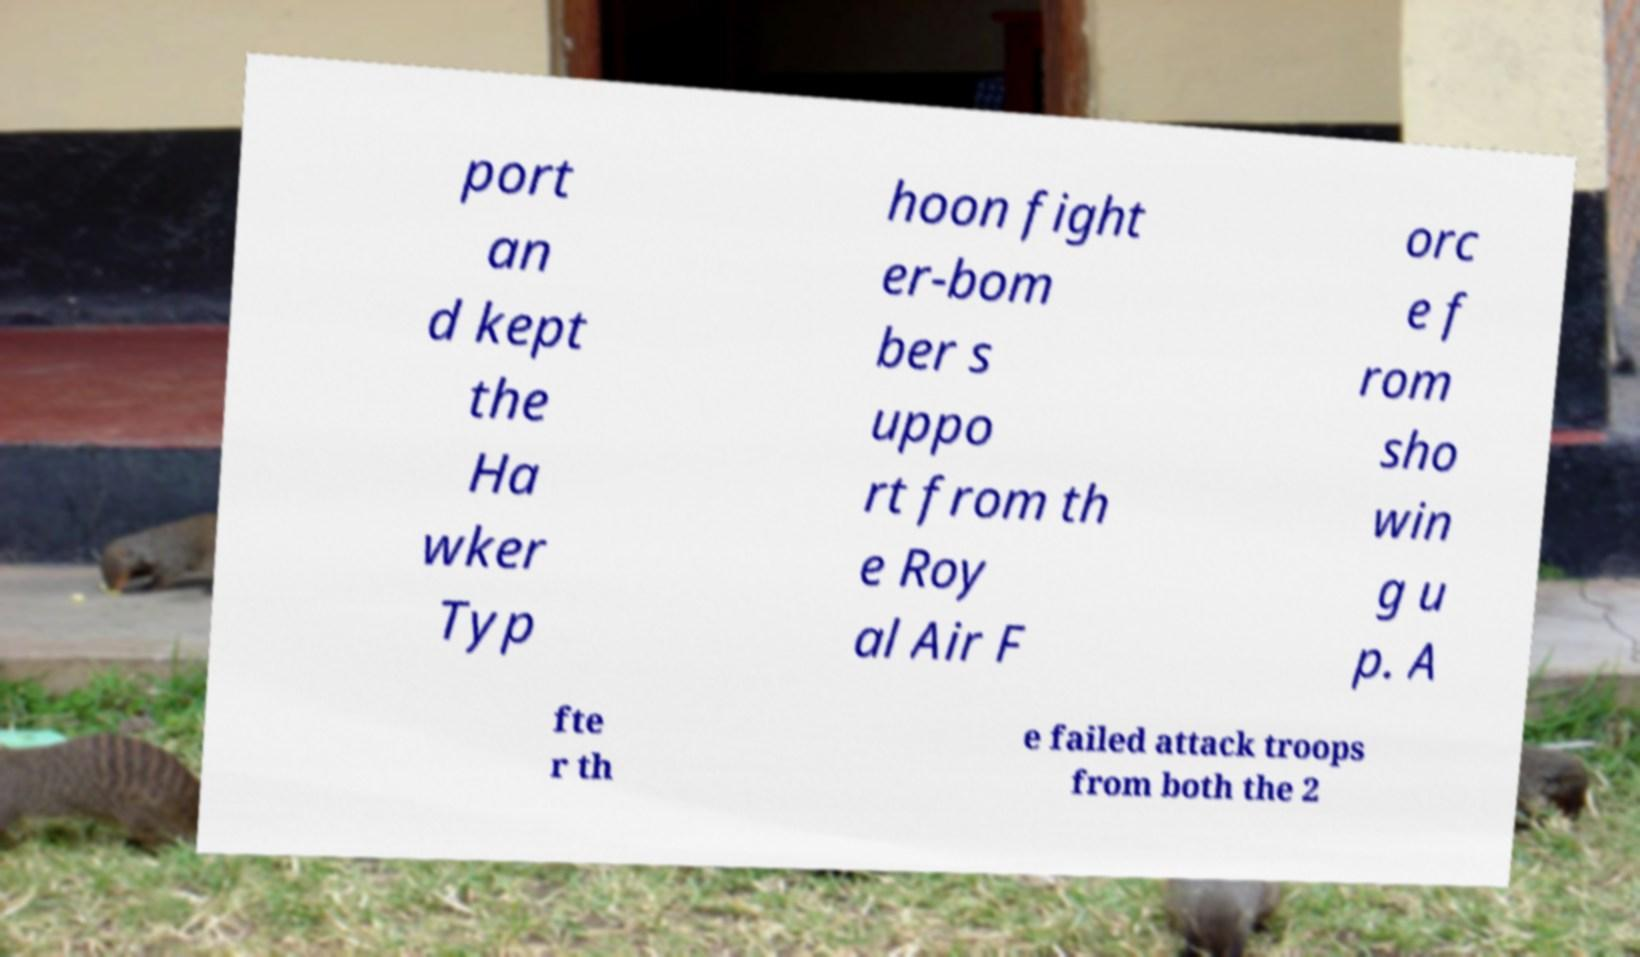Please read and relay the text visible in this image. What does it say? port an d kept the Ha wker Typ hoon fight er-bom ber s uppo rt from th e Roy al Air F orc e f rom sho win g u p. A fte r th e failed attack troops from both the 2 